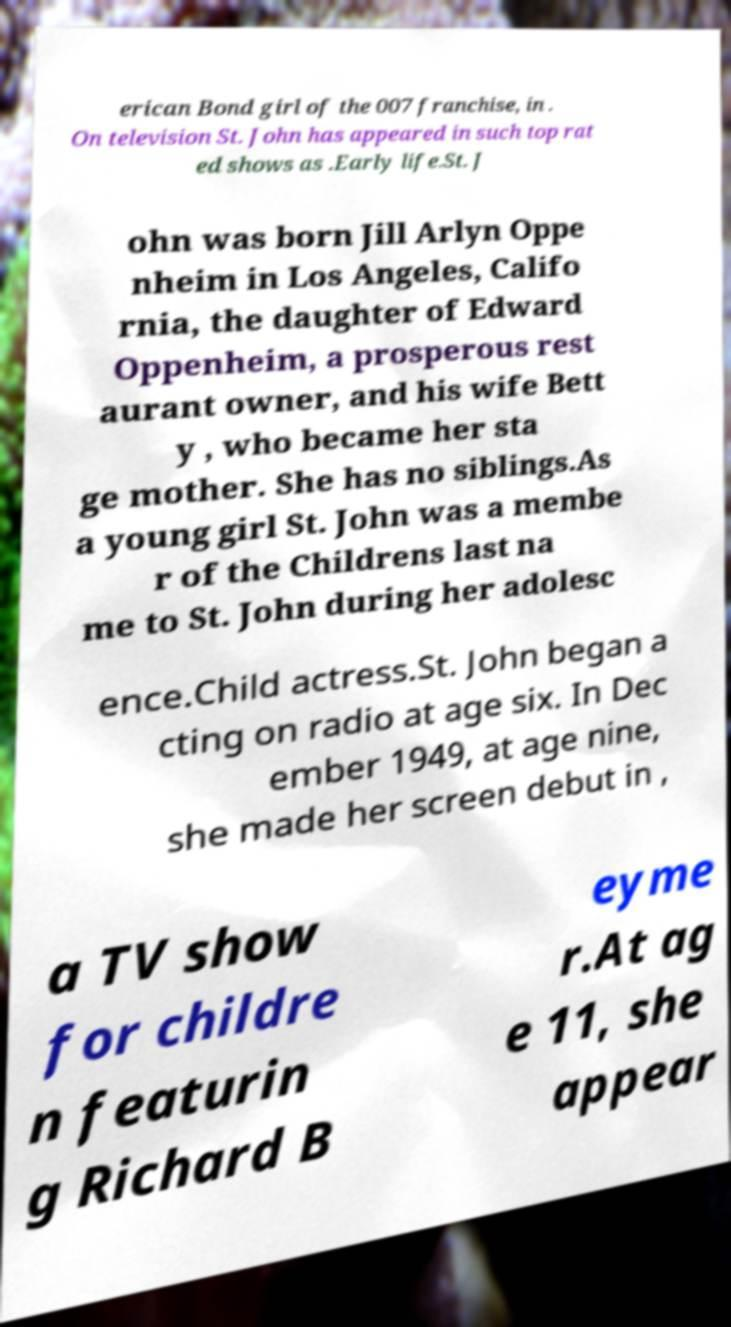Please identify and transcribe the text found in this image. erican Bond girl of the 007 franchise, in . On television St. John has appeared in such top rat ed shows as .Early life.St. J ohn was born Jill Arlyn Oppe nheim in Los Angeles, Califo rnia, the daughter of Edward Oppenheim, a prosperous rest aurant owner, and his wife Bett y , who became her sta ge mother. She has no siblings.As a young girl St. John was a membe r of the Childrens last na me to St. John during her adolesc ence.Child actress.St. John began a cting on radio at age six. In Dec ember 1949, at age nine, she made her screen debut in , a TV show for childre n featurin g Richard B eyme r.At ag e 11, she appear 